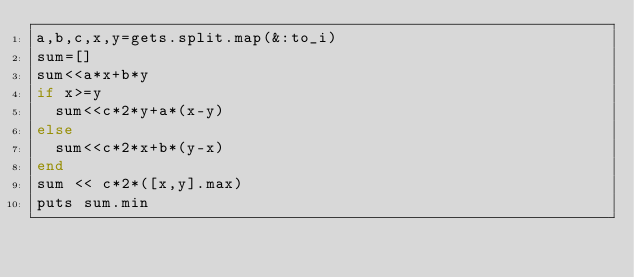<code> <loc_0><loc_0><loc_500><loc_500><_Ruby_>a,b,c,x,y=gets.split.map(&:to_i)
sum=[]
sum<<a*x+b*y
if x>=y
  sum<<c*2*y+a*(x-y)
else
  sum<<c*2*x+b*(y-x)
end
sum << c*2*([x,y].max)
puts sum.min
</code> 